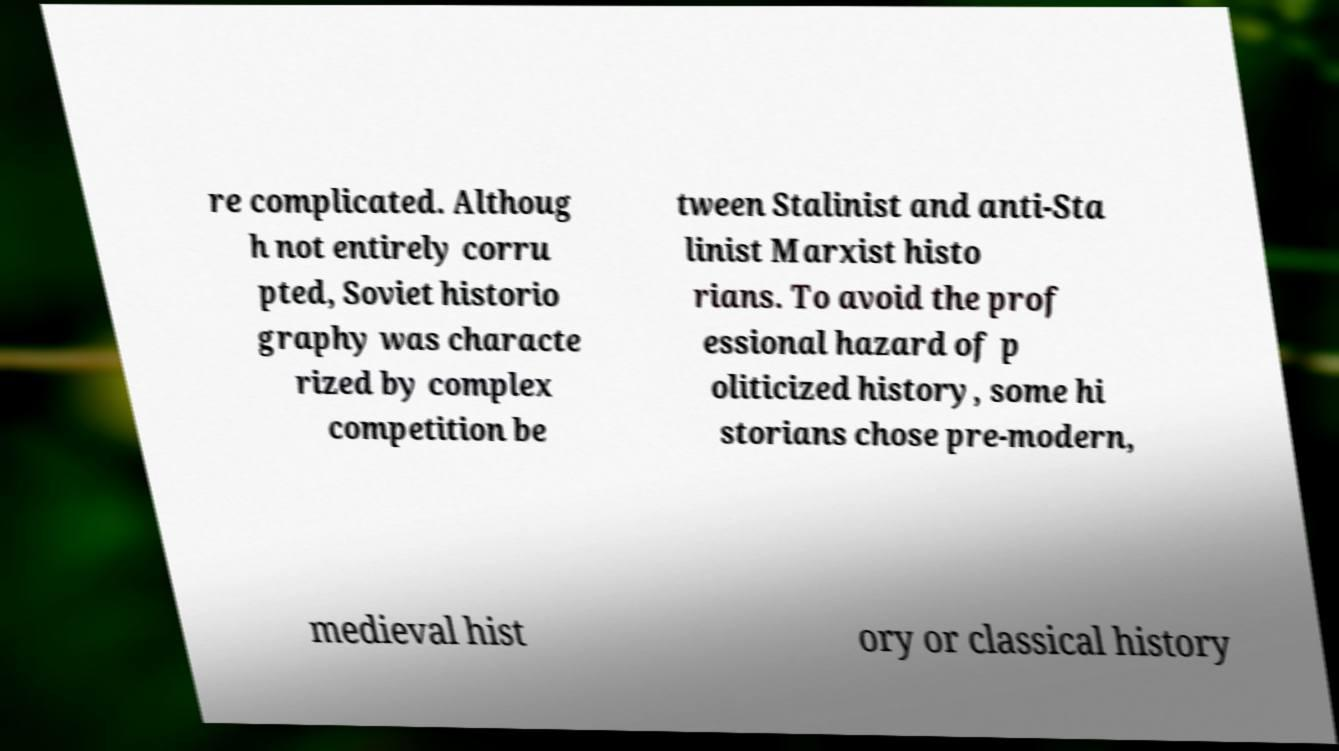Please identify and transcribe the text found in this image. re complicated. Althoug h not entirely corru pted, Soviet historio graphy was characte rized by complex competition be tween Stalinist and anti-Sta linist Marxist histo rians. To avoid the prof essional hazard of p oliticized history, some hi storians chose pre-modern, medieval hist ory or classical history 